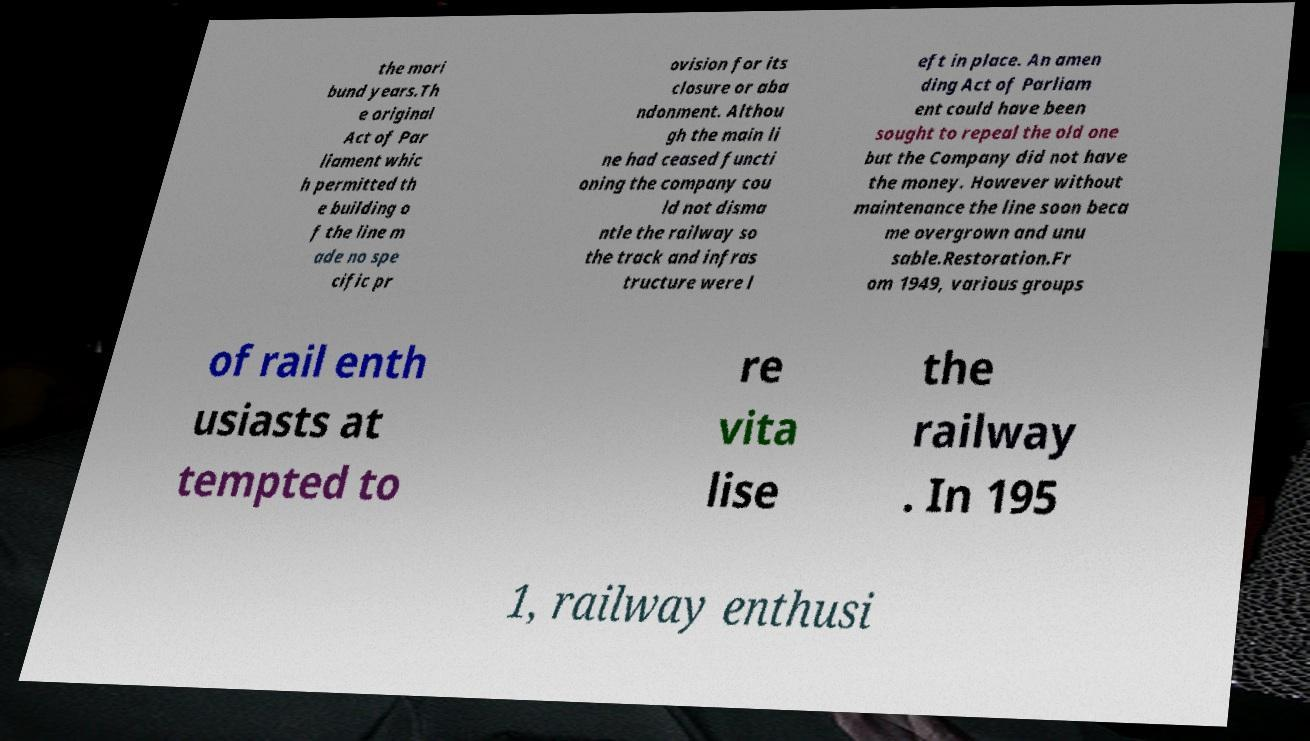Please read and relay the text visible in this image. What does it say? the mori bund years.Th e original Act of Par liament whic h permitted th e building o f the line m ade no spe cific pr ovision for its closure or aba ndonment. Althou gh the main li ne had ceased functi oning the company cou ld not disma ntle the railway so the track and infras tructure were l eft in place. An amen ding Act of Parliam ent could have been sought to repeal the old one but the Company did not have the money. However without maintenance the line soon beca me overgrown and unu sable.Restoration.Fr om 1949, various groups of rail enth usiasts at tempted to re vita lise the railway . In 195 1, railway enthusi 